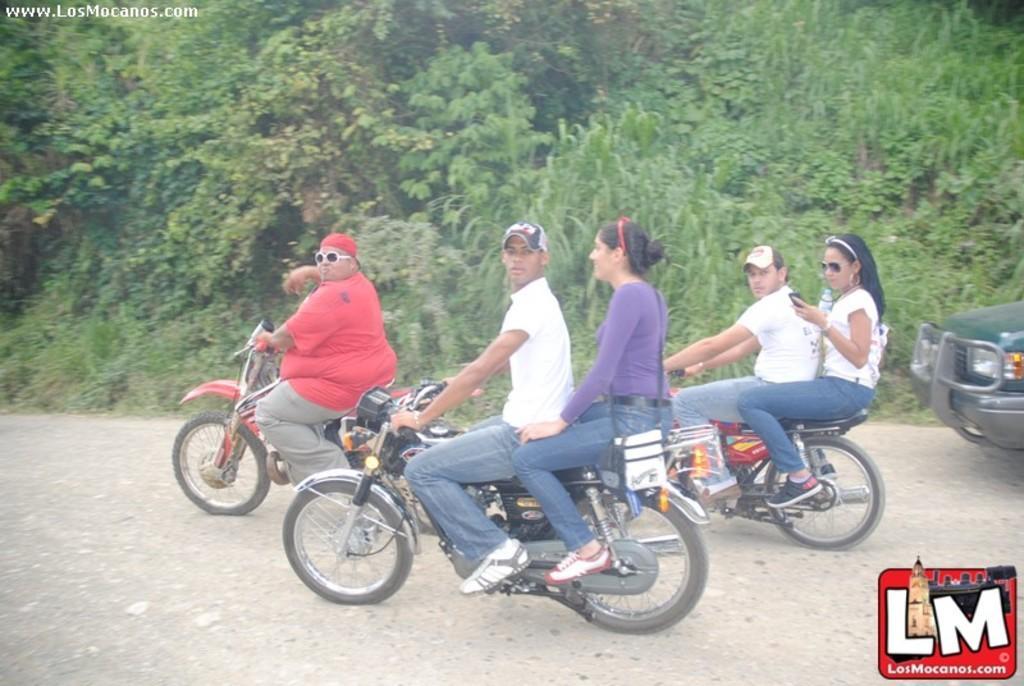Can you describe this image briefly? The picture is taken on the road where the people are riding bikes, behind them there is a car and there are trees. In the middle of the picture on the bike the man is wearing white shirt and woman behind him wearing a purple shirt and a sling bag and in the left corner of the picture the man is wearing a red shirt and glasses. 